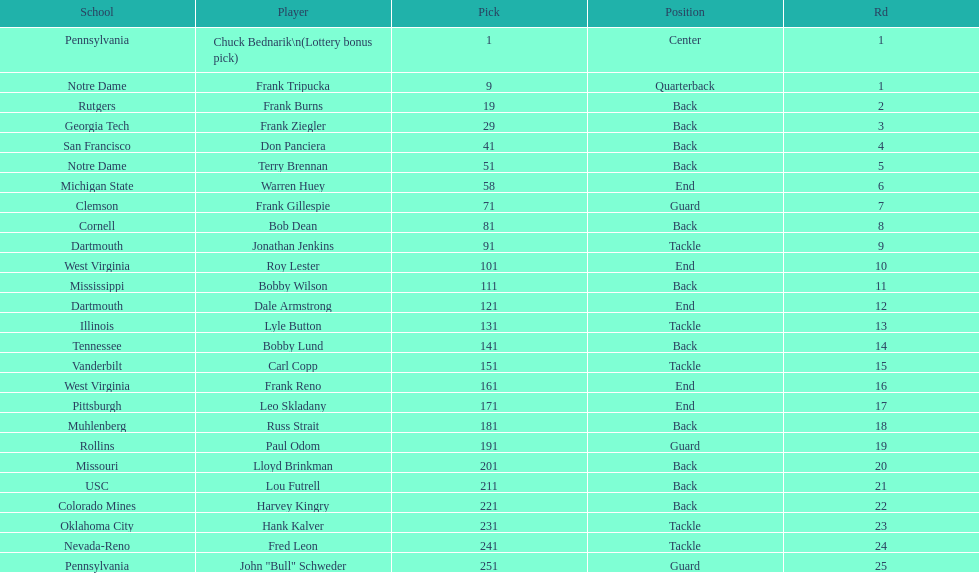What was the position that most of the players had? Back. 